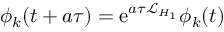Convert formula to latex. <formula><loc_0><loc_0><loc_500><loc_500>\phi _ { k } ( t + a \tau ) = e ^ { a \tau \mathcal { L } _ { H _ { 1 } } } \phi _ { k } ( t )</formula> 